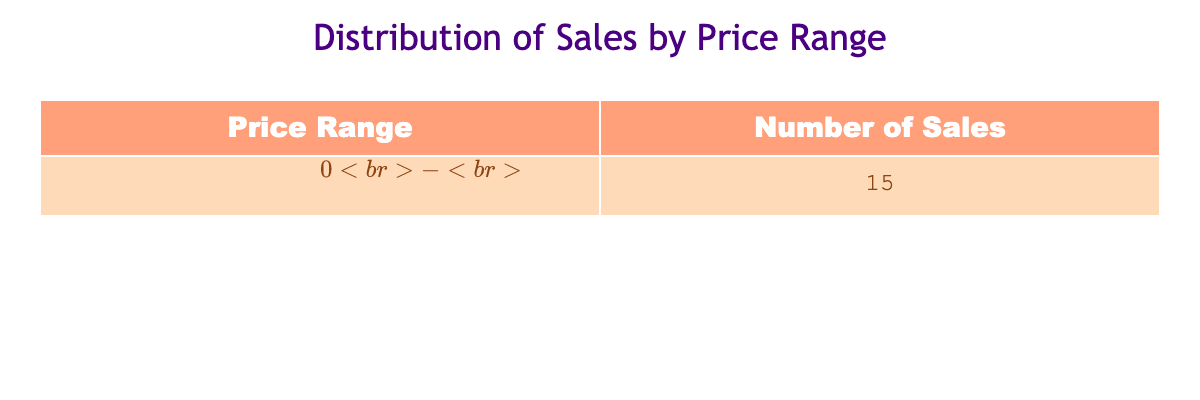What is the total number of sales in the price range of $0 - $500? The table shows the number of sales for the price range $0 - $500, which is 15.
Answer: 15 How many different price ranges are represented in the table? There is only one price range ($0 - $500) represented in the table, so the count is 1.
Answer: 1 Is there any sale recorded for artworks priced over $500? The table does not list any price range above $0 - $500, indicating there are no sales recorded for artworks priced over $500.
Answer: No What is the total number of artworks sold across all price ranges in the table? The table shows one price range, $0 - $500, with 15 sales. Therefore, the total number of artworks sold is just 15.
Answer: 15 If a new price range of $500 - $1000 were added with 10 sales, what would be the new total number of sales? Adding 10 to the current total of 15 sales for the $0 - $500 range gives a new total of 25 (15 + 10 = 25).
Answer: 25 Are there any sales recorded for artworks in the price range of $1000 and above? The table does not provide any information about sales for price ranges $1000 or above, indicating no sales are recorded in those ranges.
Answer: No What would be the average number of sales per price range if a new price range were added with 5 sales? Currently, there is one range with 15 sales. If a new range is added with 5 sales, the total number of sales would be 20 across two ranges, giving an average of 10 (20 sales divided by 2 ranges).
Answer: 10 If an additional 5 sales occurred in the current price range, what would the updated sales number be? Adding 5 sales to the existing 15 sales in the $0 - $500 range results in a new total of 20 (15 + 5 = 20).
Answer: 20 